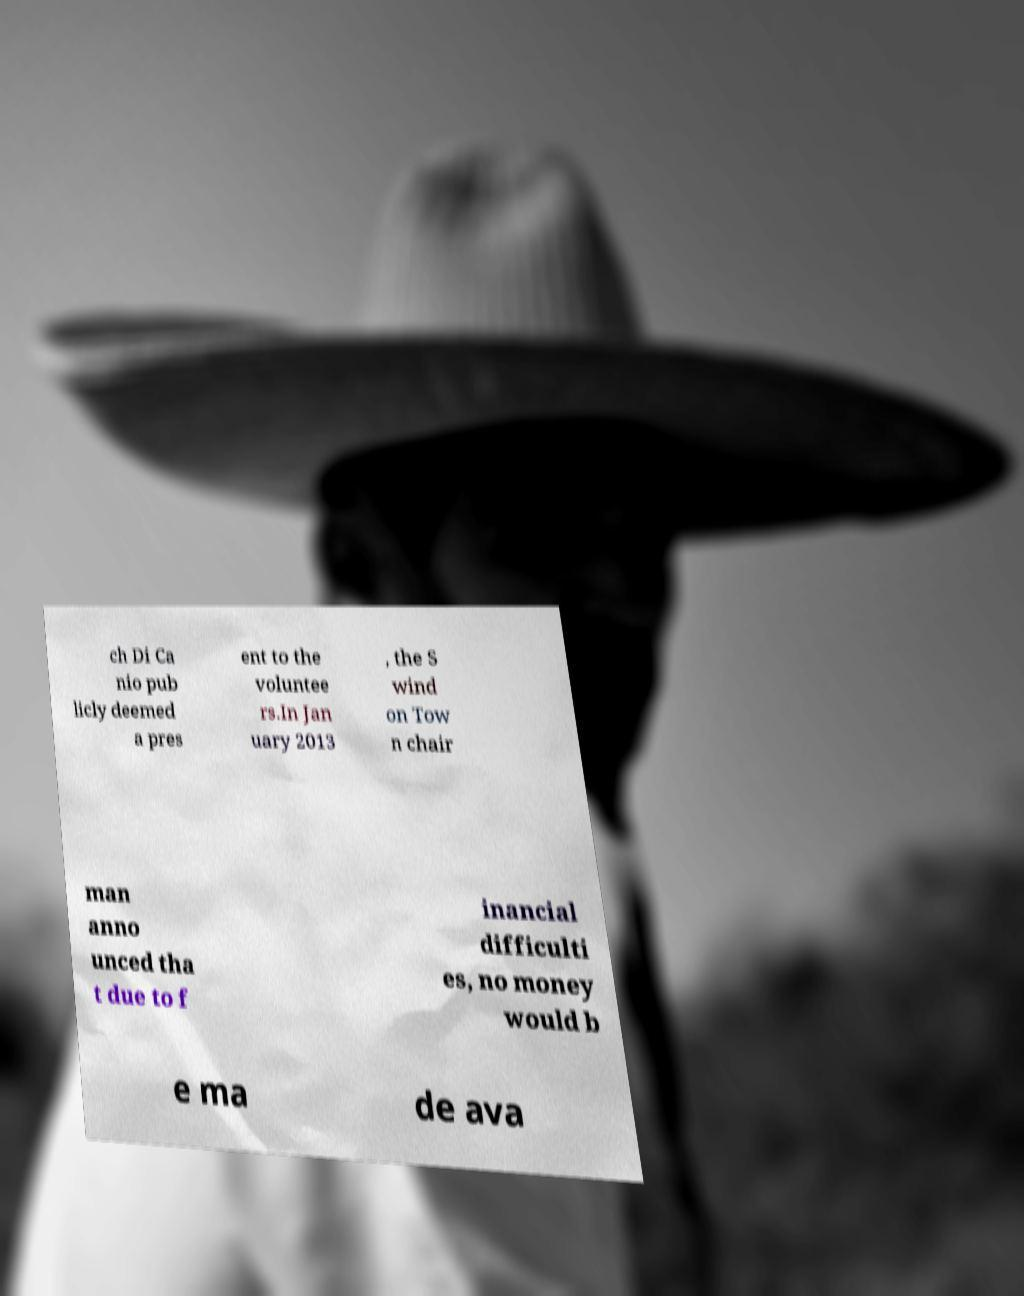Can you accurately transcribe the text from the provided image for me? ch Di Ca nio pub licly deemed a pres ent to the voluntee rs.In Jan uary 2013 , the S wind on Tow n chair man anno unced tha t due to f inancial difficulti es, no money would b e ma de ava 